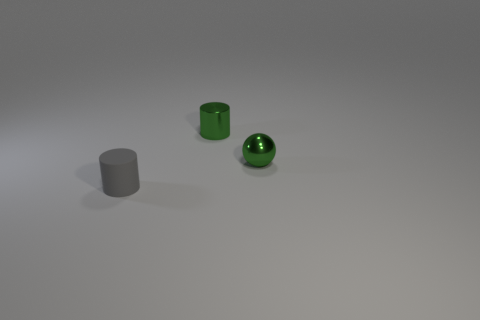What color is the thing that is both right of the tiny gray matte object and left of the small metal sphere?
Keep it short and to the point. Green. There is a green object that is the same size as the metal cylinder; what shape is it?
Your answer should be compact. Sphere. Is there another green thing that has the same shape as the small rubber object?
Ensure brevity in your answer.  Yes. Is the size of the cylinder that is behind the gray cylinder the same as the gray object?
Make the answer very short. Yes. What size is the object that is both in front of the tiny green cylinder and behind the gray rubber cylinder?
Your response must be concise. Small. What number of other objects are the same material as the gray cylinder?
Keep it short and to the point. 0. There is a object that is in front of the metallic ball; what is its size?
Offer a terse response. Small. Does the matte object have the same color as the metal cylinder?
Offer a very short reply. No. What number of large things are either green objects or cylinders?
Offer a very short reply. 0. Are there any other things that have the same color as the matte cylinder?
Offer a very short reply. No. 